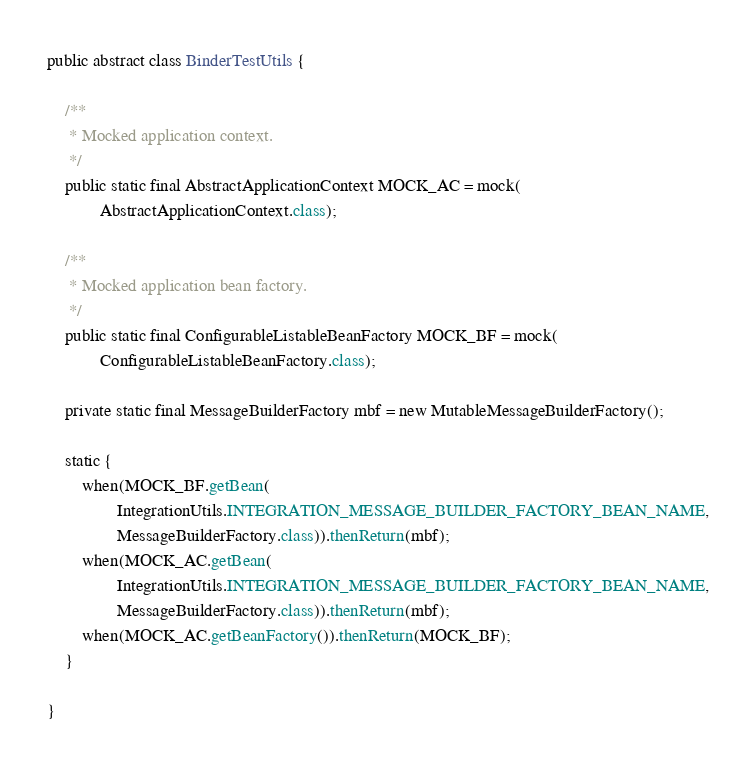Convert code to text. <code><loc_0><loc_0><loc_500><loc_500><_Java_>public abstract class BinderTestUtils {

	/**
	 * Mocked application context.
	 */
	public static final AbstractApplicationContext MOCK_AC = mock(
			AbstractApplicationContext.class);

	/**
	 * Mocked application bean factory.
	 */
	public static final ConfigurableListableBeanFactory MOCK_BF = mock(
			ConfigurableListableBeanFactory.class);

	private static final MessageBuilderFactory mbf = new MutableMessageBuilderFactory();

	static {
		when(MOCK_BF.getBean(
				IntegrationUtils.INTEGRATION_MESSAGE_BUILDER_FACTORY_BEAN_NAME,
				MessageBuilderFactory.class)).thenReturn(mbf);
		when(MOCK_AC.getBean(
				IntegrationUtils.INTEGRATION_MESSAGE_BUILDER_FACTORY_BEAN_NAME,
				MessageBuilderFactory.class)).thenReturn(mbf);
		when(MOCK_AC.getBeanFactory()).thenReturn(MOCK_BF);
	}

}
</code> 